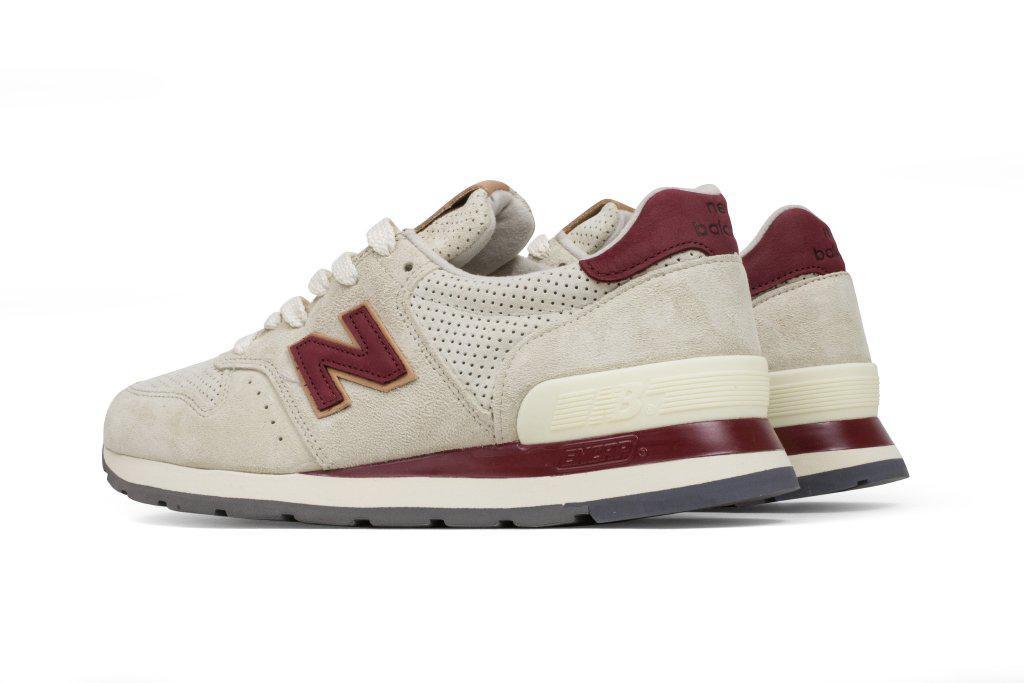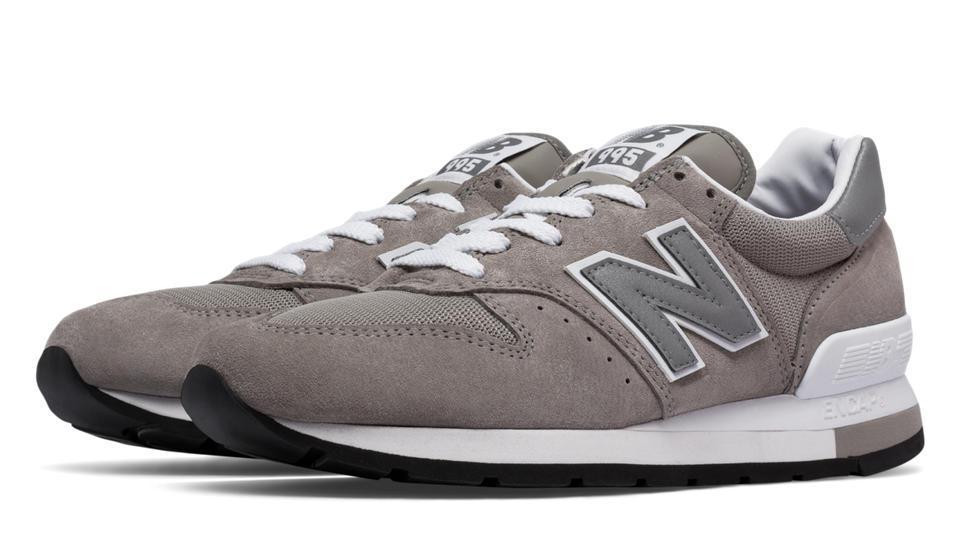The first image is the image on the left, the second image is the image on the right. For the images shown, is this caption "The shoes in each of the images are depicted in an advertisement." true? Answer yes or no. No. The first image is the image on the left, the second image is the image on the right. Considering the images on both sides, is "Left and right images contain the same number of sneakers displayed in the same position, and no human legs are depicted anywhere in either image." valid? Answer yes or no. Yes. 